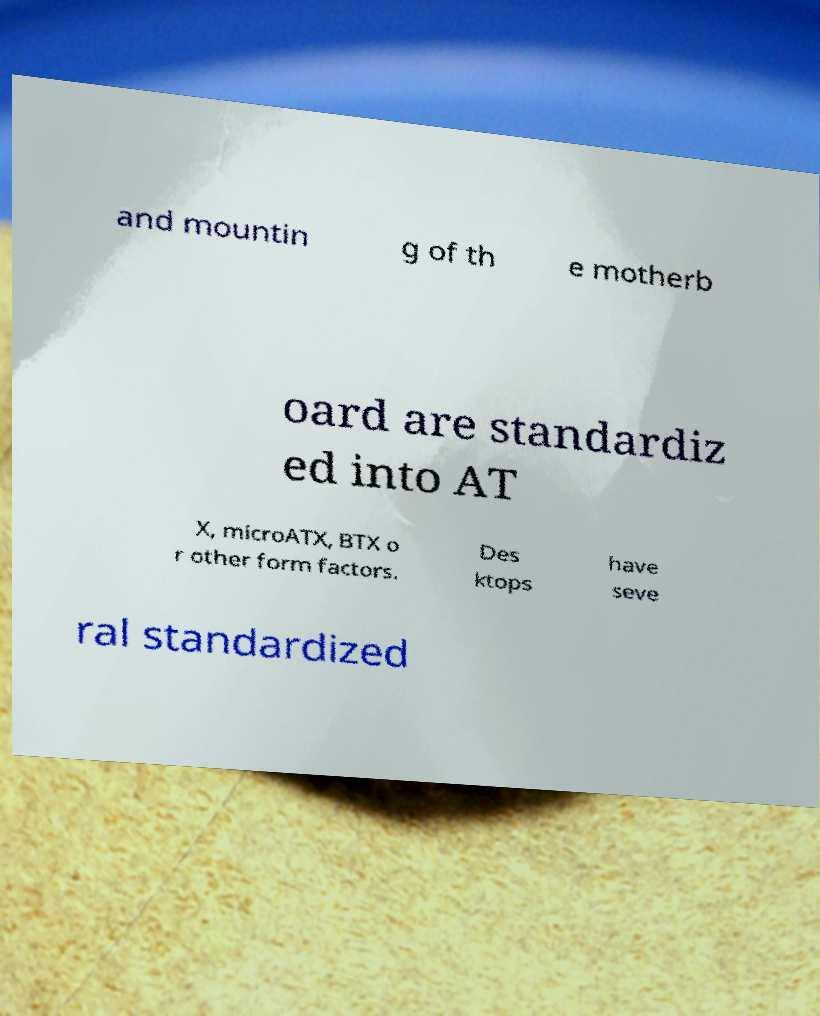Could you assist in decoding the text presented in this image and type it out clearly? and mountin g of th e motherb oard are standardiz ed into AT X, microATX, BTX o r other form factors. Des ktops have seve ral standardized 